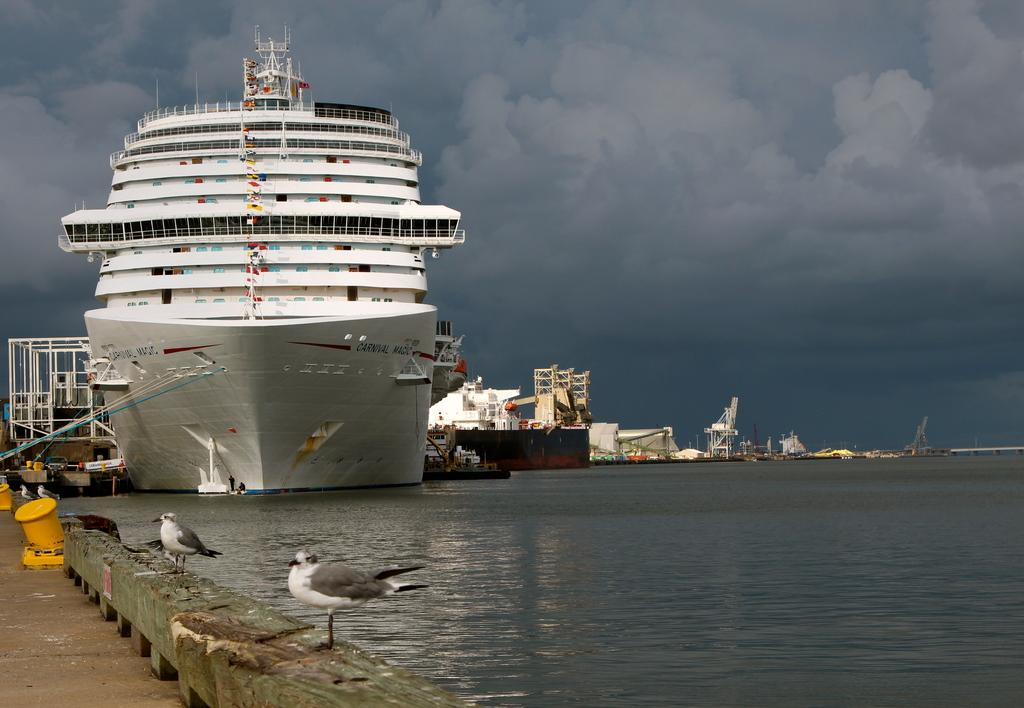What body of water is present at the bottom of the image? There is a river at the bottom of the image. What is on the river in the image? There are ships on the river. What type of animals can be seen in the image? Birds are visible in the image. What is visible in the background of the image? There is sky visible in the background of the image. How many bees are sitting on the finger of the person in the image? There is no person or bee present in the image. What type of fold can be seen in the image? There is no fold present in the image. 